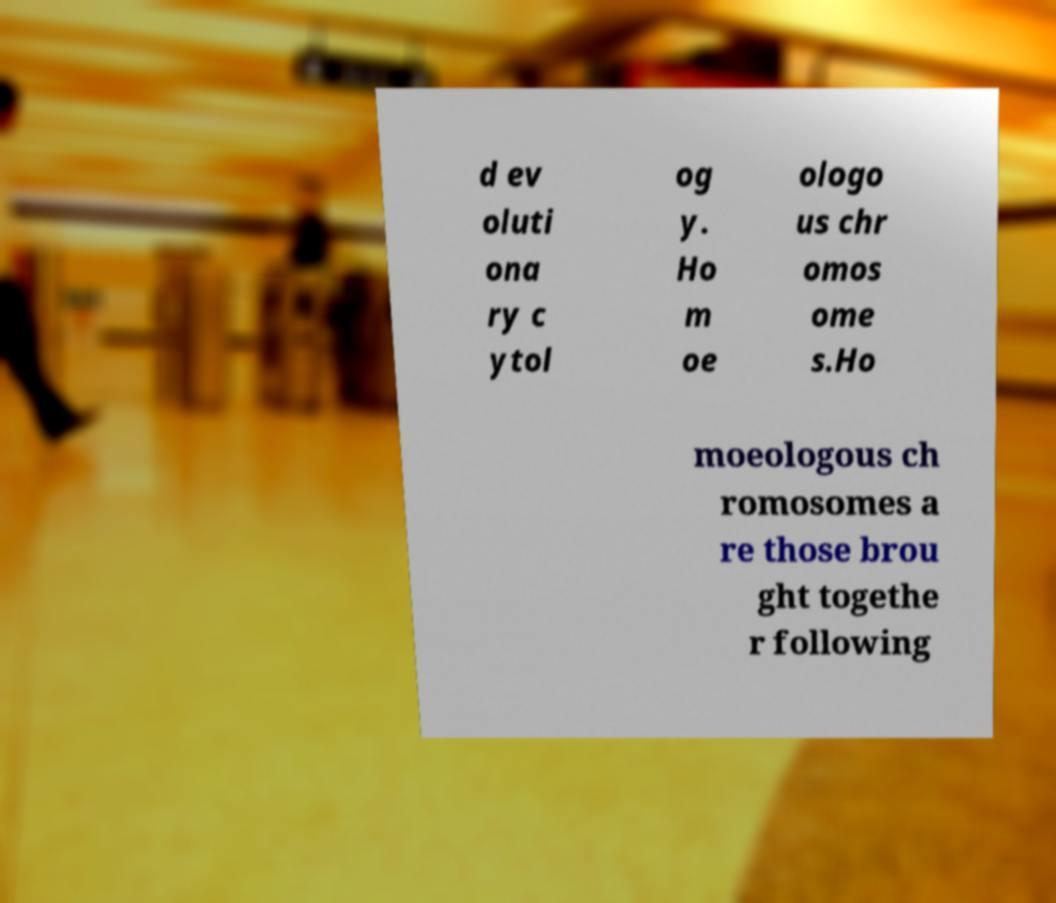There's text embedded in this image that I need extracted. Can you transcribe it verbatim? d ev oluti ona ry c ytol og y. Ho m oe ologo us chr omos ome s.Ho moeologous ch romosomes a re those brou ght togethe r following 